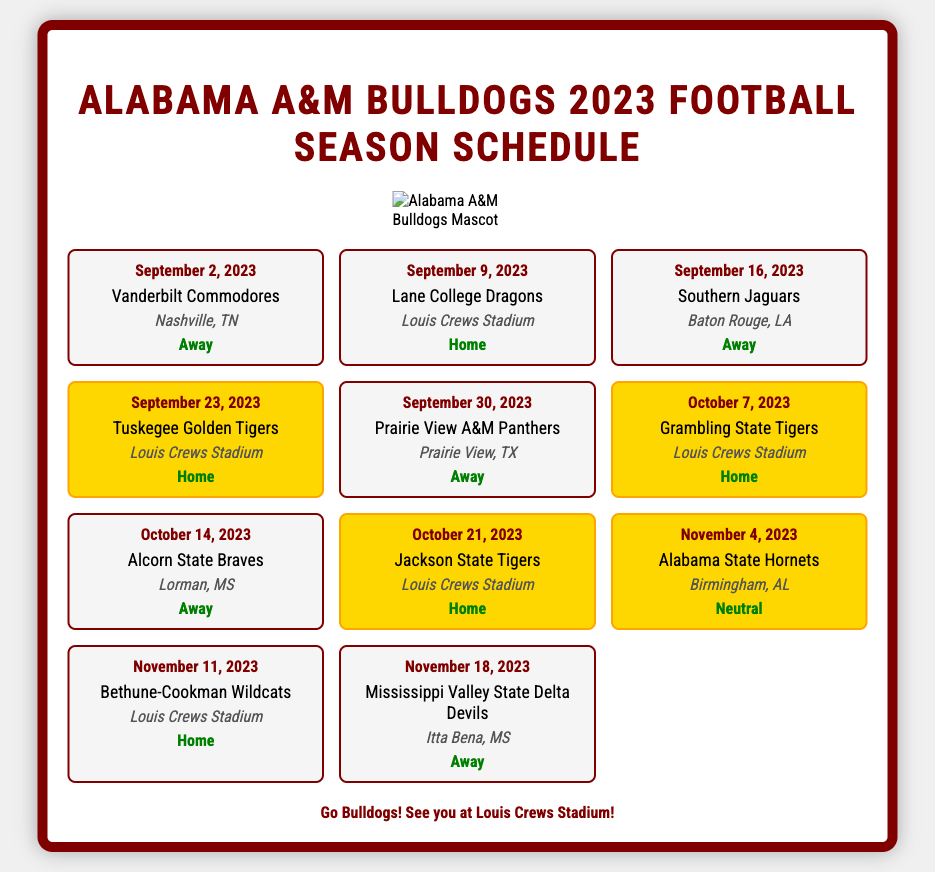What is the first game of the season? The first game listed in the schedule is on September 2, 2023, against the Vanderbilt Commodores.
Answer: Vanderbilt Commodores What is the date of the game against Lane College? The schedule specifies the game against Lane College Dragons on September 9, 2023.
Answer: September 9, 2023 How many home games are there? By counting the games with "Home" listed, the total is determined to be five home games.
Answer: 5 What is the highlight game of the season? The highlight games in the schedule are indicated by the unique styling, which includes the game against Tuskegee Golden Tigers on September 23, 2023.
Answer: Tuskegee Golden Tigers Where do the Bulldogs play their home games? The only home location given in the document is Louis Crews Stadium.
Answer: Louis Crews Stadium Which game is a neutral location? The document notes that the game against Alabama State Hornets on November 4, 2023, is a neutral site.
Answer: Alabama State Hornets What is the last away game of the season? The schedule indicates that the last away game is on November 18, 2023, against the Mississippi Valley State Delta Devils.
Answer: Mississippi Valley State Delta Devils Which opponent do the Bulldogs play on October 21, 2023? The opponent listed for that date is Jackson State Tigers.
Answer: Jackson State Tigers 